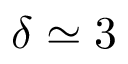<formula> <loc_0><loc_0><loc_500><loc_500>\delta \simeq 3</formula> 